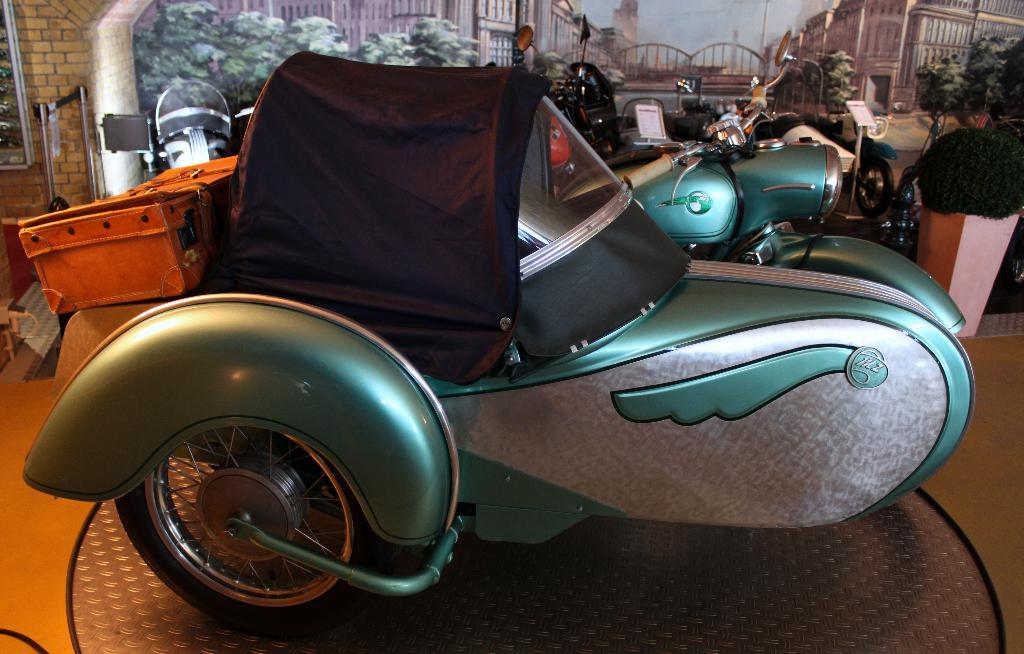What can be seen in the foreground of the image? There are vehicles in the foreground of the image. What is visible in the background of the image? There are paintings and plants in the background of the image. How many eggs are present in the image? There are no eggs visible in the image. Is it raining in the image? There is no indication of rain in the image. 